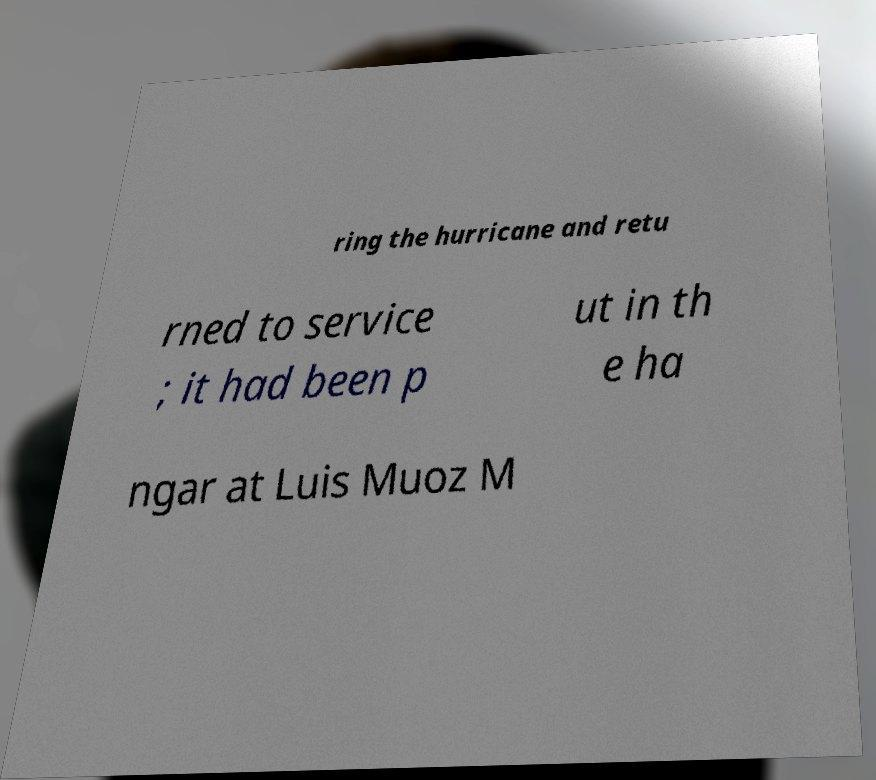Could you assist in decoding the text presented in this image and type it out clearly? ring the hurricane and retu rned to service ; it had been p ut in th e ha ngar at Luis Muoz M 